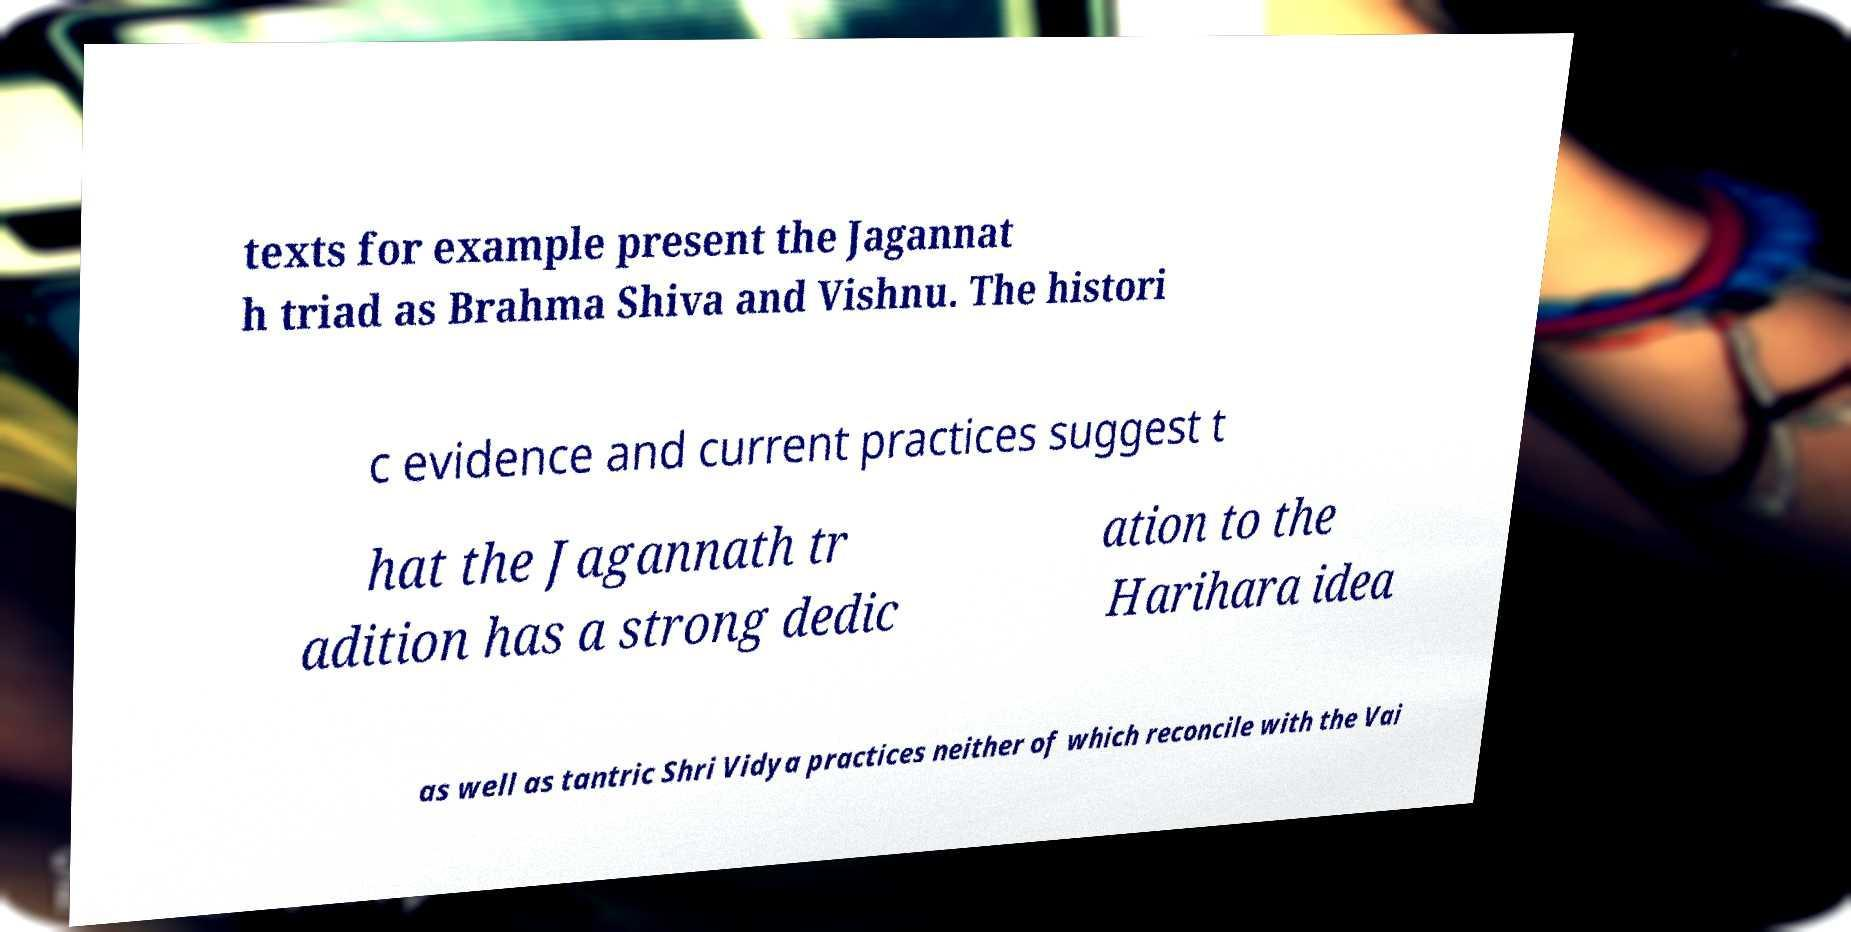Please read and relay the text visible in this image. What does it say? texts for example present the Jagannat h triad as Brahma Shiva and Vishnu. The histori c evidence and current practices suggest t hat the Jagannath tr adition has a strong dedic ation to the Harihara idea as well as tantric Shri Vidya practices neither of which reconcile with the Vai 